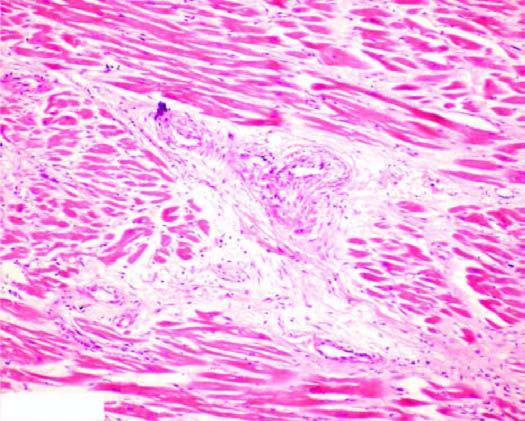s there patchy myocardial fibrosis, especially around small blood vessels in the interstitium?
Answer the question using a single word or phrase. Yes 